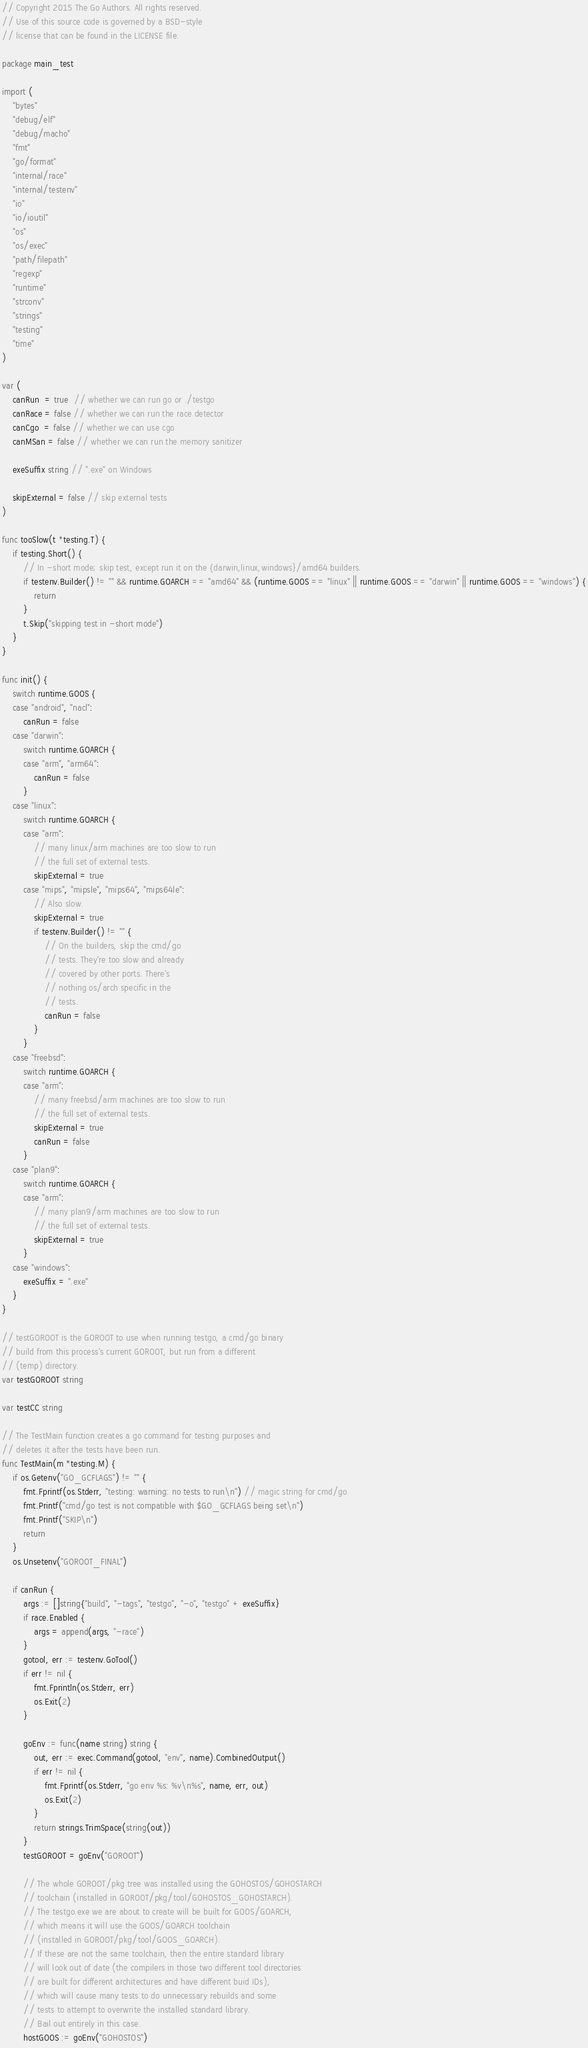<code> <loc_0><loc_0><loc_500><loc_500><_Go_>// Copyright 2015 The Go Authors. All rights reserved.
// Use of this source code is governed by a BSD-style
// license that can be found in the LICENSE file.

package main_test

import (
	"bytes"
	"debug/elf"
	"debug/macho"
	"fmt"
	"go/format"
	"internal/race"
	"internal/testenv"
	"io"
	"io/ioutil"
	"os"
	"os/exec"
	"path/filepath"
	"regexp"
	"runtime"
	"strconv"
	"strings"
	"testing"
	"time"
)

var (
	canRun  = true  // whether we can run go or ./testgo
	canRace = false // whether we can run the race detector
	canCgo  = false // whether we can use cgo
	canMSan = false // whether we can run the memory sanitizer

	exeSuffix string // ".exe" on Windows

	skipExternal = false // skip external tests
)

func tooSlow(t *testing.T) {
	if testing.Short() {
		// In -short mode; skip test, except run it on the {darwin,linux,windows}/amd64 builders.
		if testenv.Builder() != "" && runtime.GOARCH == "amd64" && (runtime.GOOS == "linux" || runtime.GOOS == "darwin" || runtime.GOOS == "windows") {
			return
		}
		t.Skip("skipping test in -short mode")
	}
}

func init() {
	switch runtime.GOOS {
	case "android", "nacl":
		canRun = false
	case "darwin":
		switch runtime.GOARCH {
		case "arm", "arm64":
			canRun = false
		}
	case "linux":
		switch runtime.GOARCH {
		case "arm":
			// many linux/arm machines are too slow to run
			// the full set of external tests.
			skipExternal = true
		case "mips", "mipsle", "mips64", "mips64le":
			// Also slow.
			skipExternal = true
			if testenv.Builder() != "" {
				// On the builders, skip the cmd/go
				// tests. They're too slow and already
				// covered by other ports. There's
				// nothing os/arch specific in the
				// tests.
				canRun = false
			}
		}
	case "freebsd":
		switch runtime.GOARCH {
		case "arm":
			// many freebsd/arm machines are too slow to run
			// the full set of external tests.
			skipExternal = true
			canRun = false
		}
	case "plan9":
		switch runtime.GOARCH {
		case "arm":
			// many plan9/arm machines are too slow to run
			// the full set of external tests.
			skipExternal = true
		}
	case "windows":
		exeSuffix = ".exe"
	}
}

// testGOROOT is the GOROOT to use when running testgo, a cmd/go binary
// build from this process's current GOROOT, but run from a different
// (temp) directory.
var testGOROOT string

var testCC string

// The TestMain function creates a go command for testing purposes and
// deletes it after the tests have been run.
func TestMain(m *testing.M) {
	if os.Getenv("GO_GCFLAGS") != "" {
		fmt.Fprintf(os.Stderr, "testing: warning: no tests to run\n") // magic string for cmd/go
		fmt.Printf("cmd/go test is not compatible with $GO_GCFLAGS being set\n")
		fmt.Printf("SKIP\n")
		return
	}
	os.Unsetenv("GOROOT_FINAL")

	if canRun {
		args := []string{"build", "-tags", "testgo", "-o", "testgo" + exeSuffix}
		if race.Enabled {
			args = append(args, "-race")
		}
		gotool, err := testenv.GoTool()
		if err != nil {
			fmt.Fprintln(os.Stderr, err)
			os.Exit(2)
		}

		goEnv := func(name string) string {
			out, err := exec.Command(gotool, "env", name).CombinedOutput()
			if err != nil {
				fmt.Fprintf(os.Stderr, "go env %s: %v\n%s", name, err, out)
				os.Exit(2)
			}
			return strings.TrimSpace(string(out))
		}
		testGOROOT = goEnv("GOROOT")

		// The whole GOROOT/pkg tree was installed using the GOHOSTOS/GOHOSTARCH
		// toolchain (installed in GOROOT/pkg/tool/GOHOSTOS_GOHOSTARCH).
		// The testgo.exe we are about to create will be built for GOOS/GOARCH,
		// which means it will use the GOOS/GOARCH toolchain
		// (installed in GOROOT/pkg/tool/GOOS_GOARCH).
		// If these are not the same toolchain, then the entire standard library
		// will look out of date (the compilers in those two different tool directories
		// are built for different architectures and have different buid IDs),
		// which will cause many tests to do unnecessary rebuilds and some
		// tests to attempt to overwrite the installed standard library.
		// Bail out entirely in this case.
		hostGOOS := goEnv("GOHOSTOS")</code> 